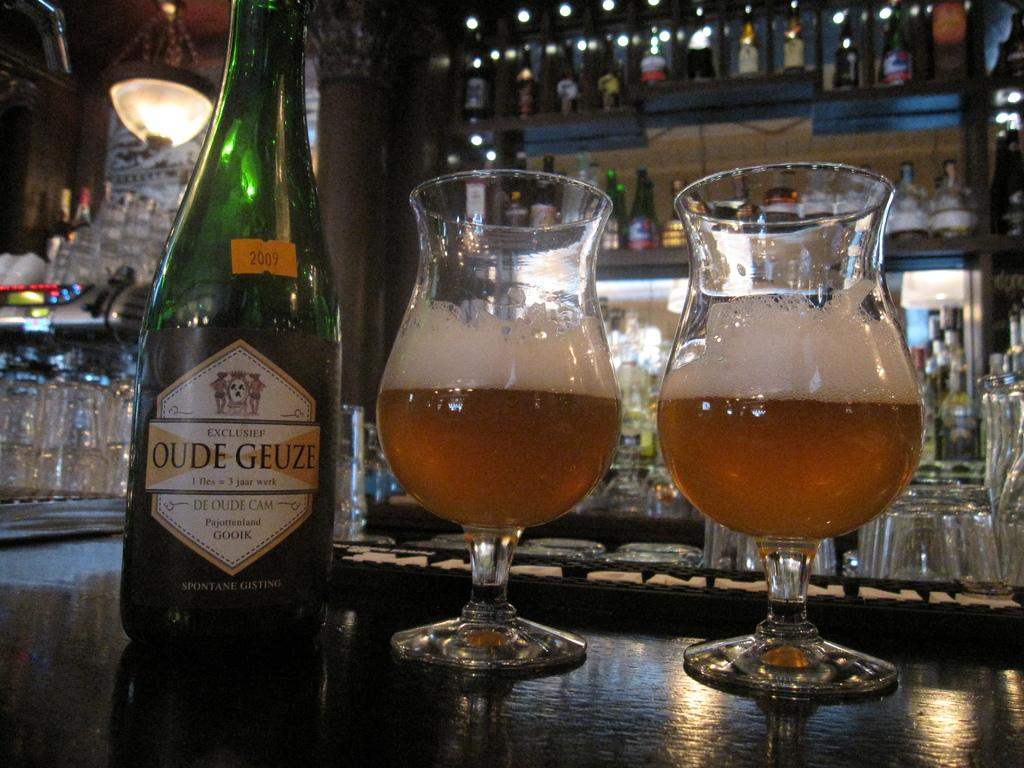<image>
Describe the image concisely. A dark green tinted glass bottle with a Oude Geuze label next to two glasses with a dark amber foamy liquid. 